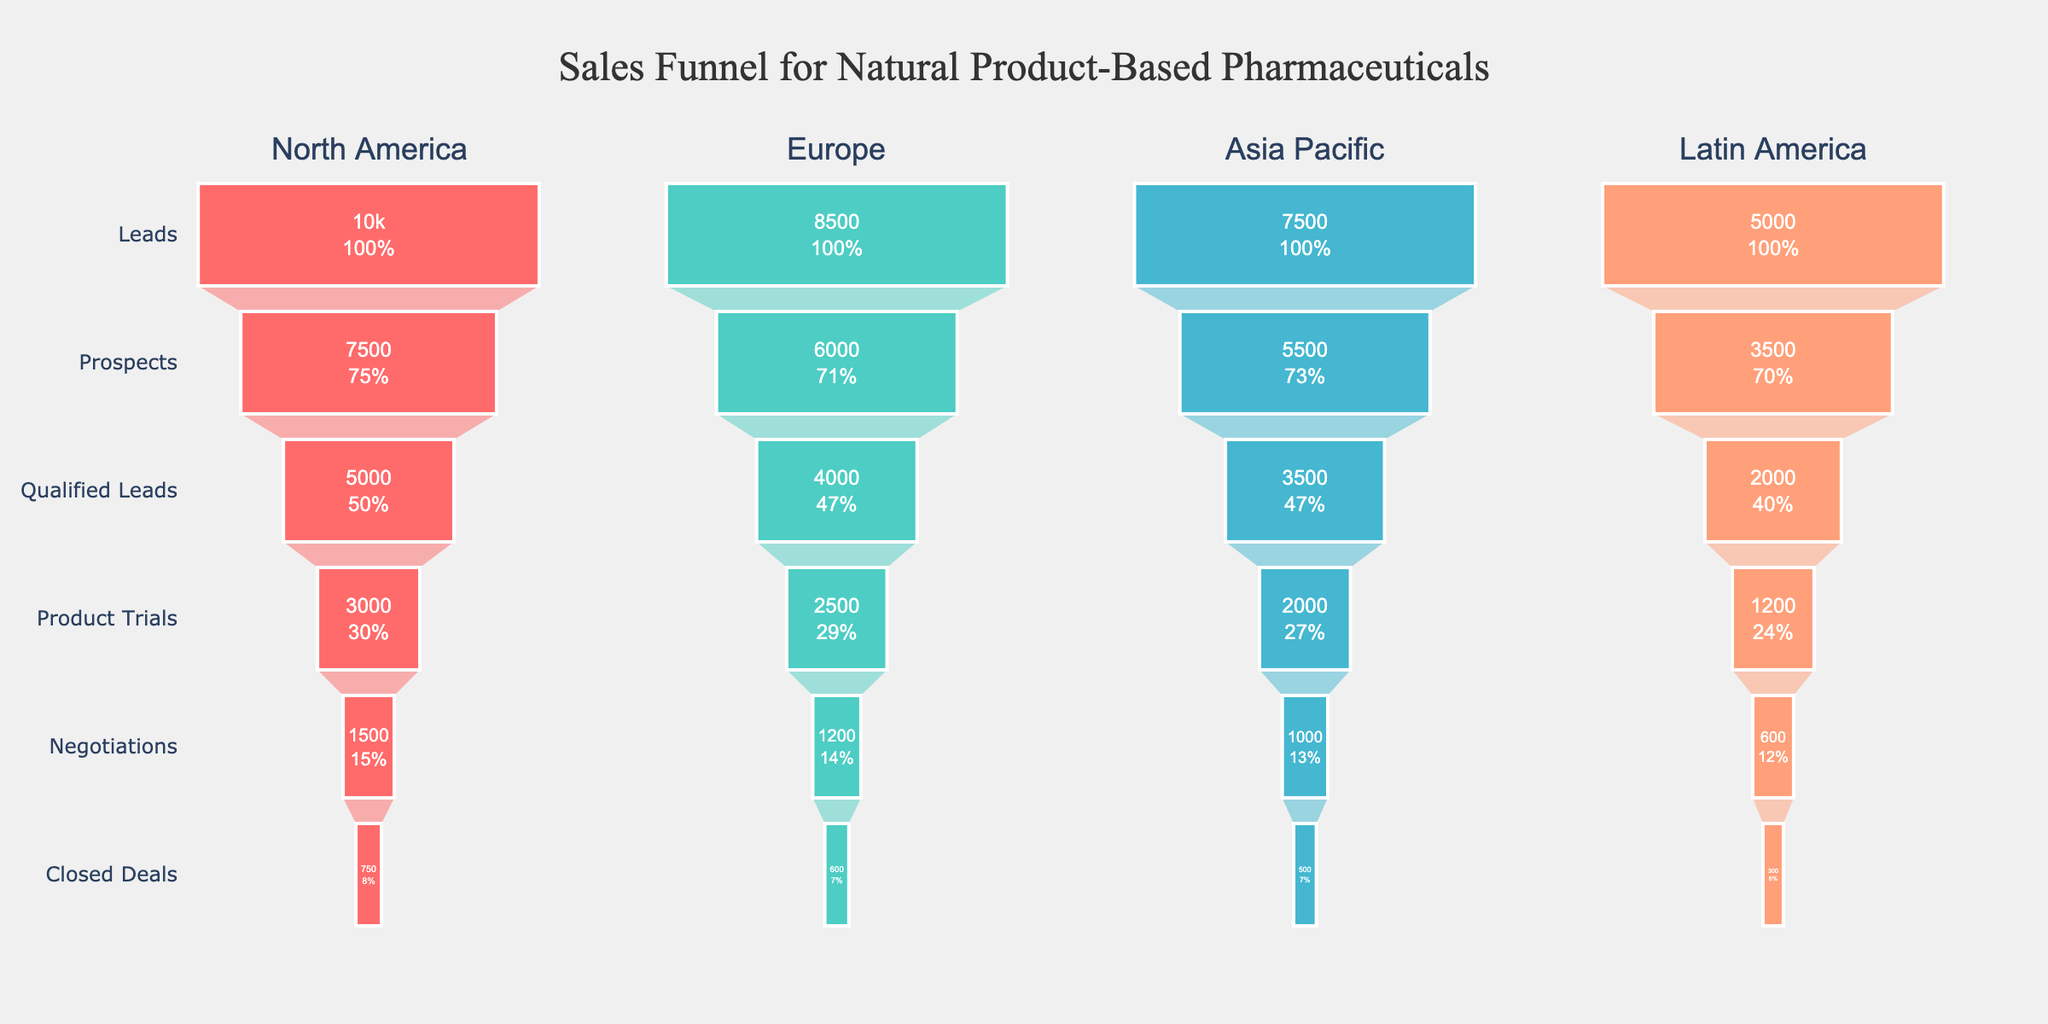How many stages are in the sales funnel? The sales funnel has distinct levels from the top to the bottom. Counting these stages will give the answer.
Answer: 6 What is the title of the chart? The text at the top of the figure indicates the chart's title.
Answer: Sales Funnel for Natural Product-Based Pharmaceuticals Which region has the highest number of leads? Look at the initial point of the funnel for each region and compare the numbers.
Answer: North America By how much does the number of closed deals in Europe differ from those in Asia Pacific? Subtract the number of closed deals in Asia Pacific from those in Europe to find the difference.
Answer: 100 What percentage of leads in Latin America progress to negotiations? The number of negotiations divided by the number of leads in Latin America, then multiplied by 100 to get the percentage.
Answer: 12% Which region has the steepest drop from prospects to qualified leads? Compare the percentage decrease from prospects to qualified leads in each region's funnel.
Answer: Latin America What is the total number of product trials across all regions? Add the number of product trials for North America, Europe, Asia Pacific, and Latin America.
Answer: 8700 Which region has the lowest number of closed deals? Find the last stage's number in each funnel and identify the smallest value.
Answer: Latin America How does the number of qualified leads in North America compare to the number of prospects in Asia Pacific? Directly compare the mentioned data points from each region's funnel.
Answer: More Which region has the highest conversion rate from qualified leads to closed deals? For each region, divide the number of closed deals by the number of qualified leads, then compare these conversion rates.
Answer: Europe 